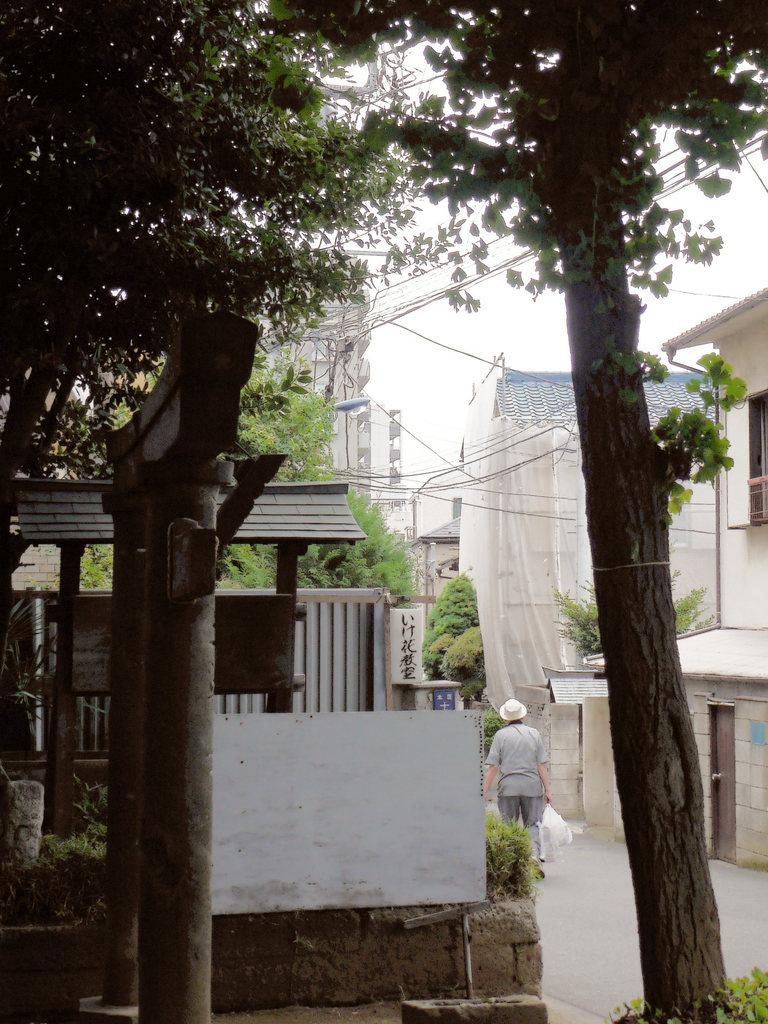What type of natural elements can be seen in the image? There are trees and plants visible in the image. What man-made structures are present in the image? There are archways, buildings, and wires visible in the image. What is the person in the image doing? The person is holding plastic covers on the road. What can be seen in the background of the image? The sky is visible in the background of the image. How many eyes can be seen on the wall in the image? There are no eyes or walls present in the image. Did the earthquake cause any damage to the buildings in the image? There is no mention of an earthquake in the image or the provided facts, so we cannot determine if any damage occurred. 